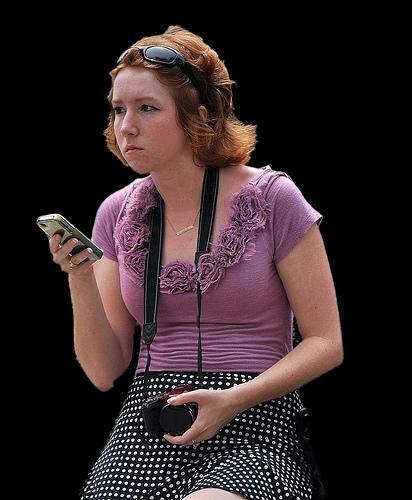How many women are there?
Give a very brief answer. 1. 